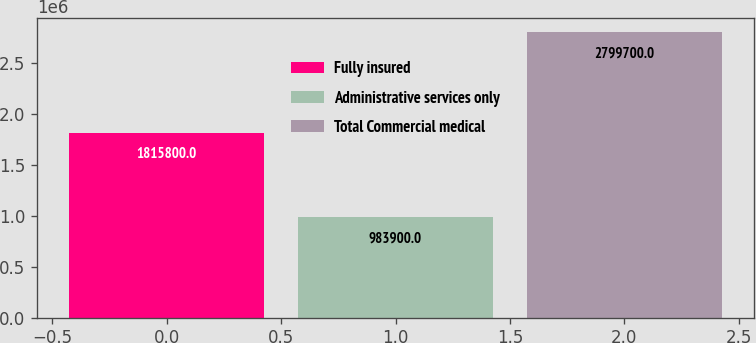<chart> <loc_0><loc_0><loc_500><loc_500><bar_chart><fcel>Fully insured<fcel>Administrative services only<fcel>Total Commercial medical<nl><fcel>1.8158e+06<fcel>983900<fcel>2.7997e+06<nl></chart> 